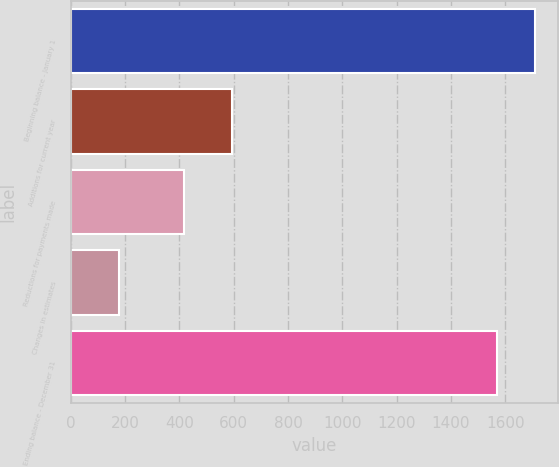Convert chart. <chart><loc_0><loc_0><loc_500><loc_500><bar_chart><fcel>Beginning balance - January 1<fcel>Additions for current year<fcel>Reductions for payments made<fcel>Changes in estimates<fcel>Ending balance - December 31<nl><fcel>1709.4<fcel>595<fcel>419<fcel>178<fcel>1570<nl></chart> 